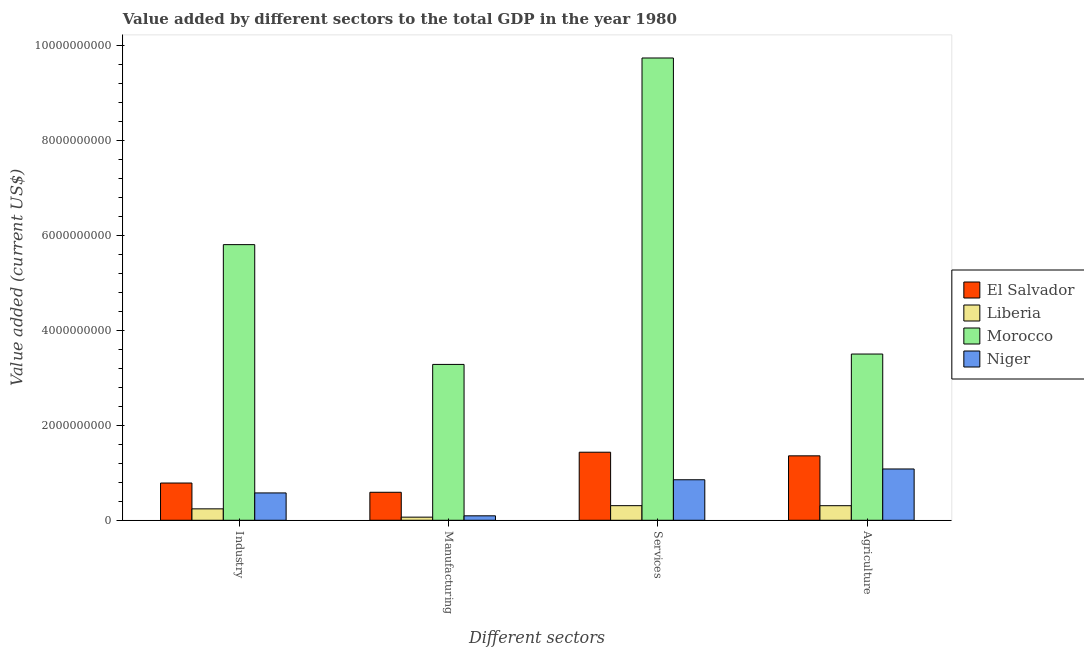How many different coloured bars are there?
Provide a succinct answer. 4. Are the number of bars per tick equal to the number of legend labels?
Make the answer very short. Yes. Are the number of bars on each tick of the X-axis equal?
Your answer should be very brief. Yes. How many bars are there on the 2nd tick from the left?
Offer a terse response. 4. What is the label of the 2nd group of bars from the left?
Give a very brief answer. Manufacturing. What is the value added by agricultural sector in Morocco?
Your answer should be very brief. 3.50e+09. Across all countries, what is the maximum value added by manufacturing sector?
Provide a succinct answer. 3.28e+09. Across all countries, what is the minimum value added by manufacturing sector?
Your response must be concise. 6.57e+07. In which country was the value added by industrial sector maximum?
Your answer should be very brief. Morocco. In which country was the value added by manufacturing sector minimum?
Make the answer very short. Liberia. What is the total value added by manufacturing sector in the graph?
Ensure brevity in your answer.  4.03e+09. What is the difference between the value added by services sector in Niger and that in Morocco?
Make the answer very short. -8.88e+09. What is the difference between the value added by agricultural sector in El Salvador and the value added by services sector in Niger?
Make the answer very short. 5.04e+08. What is the average value added by manufacturing sector per country?
Offer a very short reply. 1.01e+09. What is the difference between the value added by services sector and value added by industrial sector in Morocco?
Keep it short and to the point. 3.93e+09. What is the ratio of the value added by industrial sector in Niger to that in Morocco?
Your response must be concise. 0.1. Is the value added by manufacturing sector in El Salvador less than that in Liberia?
Keep it short and to the point. No. What is the difference between the highest and the second highest value added by industrial sector?
Provide a succinct answer. 5.02e+09. What is the difference between the highest and the lowest value added by services sector?
Your answer should be very brief. 9.43e+09. What does the 2nd bar from the left in Agriculture represents?
Make the answer very short. Liberia. What does the 3rd bar from the right in Services represents?
Give a very brief answer. Liberia. Is it the case that in every country, the sum of the value added by industrial sector and value added by manufacturing sector is greater than the value added by services sector?
Your response must be concise. No. How many bars are there?
Make the answer very short. 16. What is the difference between two consecutive major ticks on the Y-axis?
Ensure brevity in your answer.  2.00e+09. Does the graph contain grids?
Your response must be concise. No. Where does the legend appear in the graph?
Your answer should be compact. Center right. What is the title of the graph?
Offer a terse response. Value added by different sectors to the total GDP in the year 1980. What is the label or title of the X-axis?
Give a very brief answer. Different sectors. What is the label or title of the Y-axis?
Offer a terse response. Value added (current US$). What is the Value added (current US$) in El Salvador in Industry?
Offer a very short reply. 7.84e+08. What is the Value added (current US$) of Liberia in Industry?
Ensure brevity in your answer.  2.40e+08. What is the Value added (current US$) of Morocco in Industry?
Offer a very short reply. 5.80e+09. What is the Value added (current US$) of Niger in Industry?
Provide a succinct answer. 5.76e+08. What is the Value added (current US$) in El Salvador in Manufacturing?
Provide a short and direct response. 5.89e+08. What is the Value added (current US$) in Liberia in Manufacturing?
Keep it short and to the point. 6.57e+07. What is the Value added (current US$) of Morocco in Manufacturing?
Offer a very short reply. 3.28e+09. What is the Value added (current US$) of Niger in Manufacturing?
Ensure brevity in your answer.  9.37e+07. What is the Value added (current US$) in El Salvador in Services?
Your answer should be compact. 1.43e+09. What is the Value added (current US$) in Liberia in Services?
Provide a short and direct response. 3.08e+08. What is the Value added (current US$) of Morocco in Services?
Ensure brevity in your answer.  9.73e+09. What is the Value added (current US$) in Niger in Services?
Make the answer very short. 8.53e+08. What is the Value added (current US$) of El Salvador in Agriculture?
Give a very brief answer. 1.36e+09. What is the Value added (current US$) of Liberia in Agriculture?
Ensure brevity in your answer.  3.07e+08. What is the Value added (current US$) in Morocco in Agriculture?
Ensure brevity in your answer.  3.50e+09. What is the Value added (current US$) of Niger in Agriculture?
Your answer should be very brief. 1.08e+09. Across all Different sectors, what is the maximum Value added (current US$) of El Salvador?
Provide a short and direct response. 1.43e+09. Across all Different sectors, what is the maximum Value added (current US$) of Liberia?
Give a very brief answer. 3.08e+08. Across all Different sectors, what is the maximum Value added (current US$) in Morocco?
Your answer should be very brief. 9.73e+09. Across all Different sectors, what is the maximum Value added (current US$) of Niger?
Ensure brevity in your answer.  1.08e+09. Across all Different sectors, what is the minimum Value added (current US$) in El Salvador?
Keep it short and to the point. 5.89e+08. Across all Different sectors, what is the minimum Value added (current US$) of Liberia?
Make the answer very short. 6.57e+07. Across all Different sectors, what is the minimum Value added (current US$) of Morocco?
Offer a terse response. 3.28e+09. Across all Different sectors, what is the minimum Value added (current US$) of Niger?
Your answer should be compact. 9.37e+07. What is the total Value added (current US$) of El Salvador in the graph?
Keep it short and to the point. 4.16e+09. What is the total Value added (current US$) of Liberia in the graph?
Make the answer very short. 9.20e+08. What is the total Value added (current US$) of Morocco in the graph?
Offer a terse response. 2.23e+1. What is the total Value added (current US$) of Niger in the graph?
Provide a succinct answer. 2.60e+09. What is the difference between the Value added (current US$) in El Salvador in Industry and that in Manufacturing?
Your answer should be compact. 1.95e+08. What is the difference between the Value added (current US$) of Liberia in Industry and that in Manufacturing?
Give a very brief answer. 1.75e+08. What is the difference between the Value added (current US$) of Morocco in Industry and that in Manufacturing?
Ensure brevity in your answer.  2.52e+09. What is the difference between the Value added (current US$) of Niger in Industry and that in Manufacturing?
Give a very brief answer. 4.82e+08. What is the difference between the Value added (current US$) in El Salvador in Industry and that in Services?
Provide a short and direct response. -6.49e+08. What is the difference between the Value added (current US$) of Liberia in Industry and that in Services?
Give a very brief answer. -6.71e+07. What is the difference between the Value added (current US$) of Morocco in Industry and that in Services?
Ensure brevity in your answer.  -3.93e+09. What is the difference between the Value added (current US$) in Niger in Industry and that in Services?
Your response must be concise. -2.77e+08. What is the difference between the Value added (current US$) in El Salvador in Industry and that in Agriculture?
Give a very brief answer. -5.72e+08. What is the difference between the Value added (current US$) in Liberia in Industry and that in Agriculture?
Your answer should be compact. -6.63e+07. What is the difference between the Value added (current US$) in Morocco in Industry and that in Agriculture?
Your answer should be very brief. 2.30e+09. What is the difference between the Value added (current US$) in Niger in Industry and that in Agriculture?
Your answer should be very brief. -5.05e+08. What is the difference between the Value added (current US$) in El Salvador in Manufacturing and that in Services?
Ensure brevity in your answer.  -8.44e+08. What is the difference between the Value added (current US$) of Liberia in Manufacturing and that in Services?
Provide a short and direct response. -2.42e+08. What is the difference between the Value added (current US$) in Morocco in Manufacturing and that in Services?
Give a very brief answer. -6.45e+09. What is the difference between the Value added (current US$) of Niger in Manufacturing and that in Services?
Provide a short and direct response. -7.59e+08. What is the difference between the Value added (current US$) of El Salvador in Manufacturing and that in Agriculture?
Offer a terse response. -7.67e+08. What is the difference between the Value added (current US$) in Liberia in Manufacturing and that in Agriculture?
Your response must be concise. -2.41e+08. What is the difference between the Value added (current US$) in Morocco in Manufacturing and that in Agriculture?
Keep it short and to the point. -2.18e+08. What is the difference between the Value added (current US$) in Niger in Manufacturing and that in Agriculture?
Provide a succinct answer. -9.86e+08. What is the difference between the Value added (current US$) of El Salvador in Services and that in Agriculture?
Keep it short and to the point. 7.64e+07. What is the difference between the Value added (current US$) of Liberia in Services and that in Agriculture?
Make the answer very short. 8.54e+05. What is the difference between the Value added (current US$) in Morocco in Services and that in Agriculture?
Offer a very short reply. 6.23e+09. What is the difference between the Value added (current US$) in Niger in Services and that in Agriculture?
Your answer should be very brief. -2.27e+08. What is the difference between the Value added (current US$) in El Salvador in Industry and the Value added (current US$) in Liberia in Manufacturing?
Offer a very short reply. 7.19e+08. What is the difference between the Value added (current US$) of El Salvador in Industry and the Value added (current US$) of Morocco in Manufacturing?
Your answer should be very brief. -2.50e+09. What is the difference between the Value added (current US$) in El Salvador in Industry and the Value added (current US$) in Niger in Manufacturing?
Make the answer very short. 6.91e+08. What is the difference between the Value added (current US$) in Liberia in Industry and the Value added (current US$) in Morocco in Manufacturing?
Offer a terse response. -3.04e+09. What is the difference between the Value added (current US$) of Liberia in Industry and the Value added (current US$) of Niger in Manufacturing?
Give a very brief answer. 1.47e+08. What is the difference between the Value added (current US$) of Morocco in Industry and the Value added (current US$) of Niger in Manufacturing?
Your answer should be compact. 5.71e+09. What is the difference between the Value added (current US$) of El Salvador in Industry and the Value added (current US$) of Liberia in Services?
Your answer should be compact. 4.77e+08. What is the difference between the Value added (current US$) of El Salvador in Industry and the Value added (current US$) of Morocco in Services?
Give a very brief answer. -8.95e+09. What is the difference between the Value added (current US$) of El Salvador in Industry and the Value added (current US$) of Niger in Services?
Offer a very short reply. -6.86e+07. What is the difference between the Value added (current US$) of Liberia in Industry and the Value added (current US$) of Morocco in Services?
Give a very brief answer. -9.49e+09. What is the difference between the Value added (current US$) in Liberia in Industry and the Value added (current US$) in Niger in Services?
Your answer should be very brief. -6.12e+08. What is the difference between the Value added (current US$) of Morocco in Industry and the Value added (current US$) of Niger in Services?
Provide a succinct answer. 4.95e+09. What is the difference between the Value added (current US$) in El Salvador in Industry and the Value added (current US$) in Liberia in Agriculture?
Your answer should be compact. 4.78e+08. What is the difference between the Value added (current US$) of El Salvador in Industry and the Value added (current US$) of Morocco in Agriculture?
Give a very brief answer. -2.72e+09. What is the difference between the Value added (current US$) in El Salvador in Industry and the Value added (current US$) in Niger in Agriculture?
Offer a terse response. -2.96e+08. What is the difference between the Value added (current US$) in Liberia in Industry and the Value added (current US$) in Morocco in Agriculture?
Make the answer very short. -3.26e+09. What is the difference between the Value added (current US$) in Liberia in Industry and the Value added (current US$) in Niger in Agriculture?
Ensure brevity in your answer.  -8.40e+08. What is the difference between the Value added (current US$) of Morocco in Industry and the Value added (current US$) of Niger in Agriculture?
Your response must be concise. 4.72e+09. What is the difference between the Value added (current US$) of El Salvador in Manufacturing and the Value added (current US$) of Liberia in Services?
Provide a succinct answer. 2.82e+08. What is the difference between the Value added (current US$) in El Salvador in Manufacturing and the Value added (current US$) in Morocco in Services?
Ensure brevity in your answer.  -9.14e+09. What is the difference between the Value added (current US$) of El Salvador in Manufacturing and the Value added (current US$) of Niger in Services?
Make the answer very short. -2.63e+08. What is the difference between the Value added (current US$) of Liberia in Manufacturing and the Value added (current US$) of Morocco in Services?
Offer a very short reply. -9.67e+09. What is the difference between the Value added (current US$) of Liberia in Manufacturing and the Value added (current US$) of Niger in Services?
Your answer should be compact. -7.87e+08. What is the difference between the Value added (current US$) of Morocco in Manufacturing and the Value added (current US$) of Niger in Services?
Keep it short and to the point. 2.43e+09. What is the difference between the Value added (current US$) of El Salvador in Manufacturing and the Value added (current US$) of Liberia in Agriculture?
Offer a terse response. 2.83e+08. What is the difference between the Value added (current US$) in El Salvador in Manufacturing and the Value added (current US$) in Morocco in Agriculture?
Ensure brevity in your answer.  -2.91e+09. What is the difference between the Value added (current US$) in El Salvador in Manufacturing and the Value added (current US$) in Niger in Agriculture?
Give a very brief answer. -4.91e+08. What is the difference between the Value added (current US$) in Liberia in Manufacturing and the Value added (current US$) in Morocco in Agriculture?
Your response must be concise. -3.43e+09. What is the difference between the Value added (current US$) in Liberia in Manufacturing and the Value added (current US$) in Niger in Agriculture?
Your answer should be compact. -1.01e+09. What is the difference between the Value added (current US$) of Morocco in Manufacturing and the Value added (current US$) of Niger in Agriculture?
Give a very brief answer. 2.20e+09. What is the difference between the Value added (current US$) in El Salvador in Services and the Value added (current US$) in Liberia in Agriculture?
Your answer should be very brief. 1.13e+09. What is the difference between the Value added (current US$) of El Salvador in Services and the Value added (current US$) of Morocco in Agriculture?
Provide a short and direct response. -2.07e+09. What is the difference between the Value added (current US$) in El Salvador in Services and the Value added (current US$) in Niger in Agriculture?
Offer a very short reply. 3.53e+08. What is the difference between the Value added (current US$) in Liberia in Services and the Value added (current US$) in Morocco in Agriculture?
Provide a succinct answer. -3.19e+09. What is the difference between the Value added (current US$) of Liberia in Services and the Value added (current US$) of Niger in Agriculture?
Offer a terse response. -7.73e+08. What is the difference between the Value added (current US$) of Morocco in Services and the Value added (current US$) of Niger in Agriculture?
Your answer should be very brief. 8.65e+09. What is the average Value added (current US$) of El Salvador per Different sectors?
Keep it short and to the point. 1.04e+09. What is the average Value added (current US$) of Liberia per Different sectors?
Offer a terse response. 2.30e+08. What is the average Value added (current US$) of Morocco per Different sectors?
Offer a very short reply. 5.58e+09. What is the average Value added (current US$) of Niger per Different sectors?
Offer a terse response. 6.51e+08. What is the difference between the Value added (current US$) in El Salvador and Value added (current US$) in Liberia in Industry?
Provide a succinct answer. 5.44e+08. What is the difference between the Value added (current US$) of El Salvador and Value added (current US$) of Morocco in Industry?
Ensure brevity in your answer.  -5.02e+09. What is the difference between the Value added (current US$) of El Salvador and Value added (current US$) of Niger in Industry?
Make the answer very short. 2.09e+08. What is the difference between the Value added (current US$) in Liberia and Value added (current US$) in Morocco in Industry?
Your answer should be compact. -5.56e+09. What is the difference between the Value added (current US$) in Liberia and Value added (current US$) in Niger in Industry?
Your response must be concise. -3.35e+08. What is the difference between the Value added (current US$) in Morocco and Value added (current US$) in Niger in Industry?
Give a very brief answer. 5.23e+09. What is the difference between the Value added (current US$) in El Salvador and Value added (current US$) in Liberia in Manufacturing?
Your answer should be very brief. 5.24e+08. What is the difference between the Value added (current US$) of El Salvador and Value added (current US$) of Morocco in Manufacturing?
Ensure brevity in your answer.  -2.69e+09. What is the difference between the Value added (current US$) of El Salvador and Value added (current US$) of Niger in Manufacturing?
Provide a succinct answer. 4.96e+08. What is the difference between the Value added (current US$) of Liberia and Value added (current US$) of Morocco in Manufacturing?
Your answer should be compact. -3.22e+09. What is the difference between the Value added (current US$) of Liberia and Value added (current US$) of Niger in Manufacturing?
Ensure brevity in your answer.  -2.80e+07. What is the difference between the Value added (current US$) in Morocco and Value added (current US$) in Niger in Manufacturing?
Keep it short and to the point. 3.19e+09. What is the difference between the Value added (current US$) in El Salvador and Value added (current US$) in Liberia in Services?
Offer a very short reply. 1.13e+09. What is the difference between the Value added (current US$) of El Salvador and Value added (current US$) of Morocco in Services?
Offer a terse response. -8.30e+09. What is the difference between the Value added (current US$) in El Salvador and Value added (current US$) in Niger in Services?
Your response must be concise. 5.80e+08. What is the difference between the Value added (current US$) of Liberia and Value added (current US$) of Morocco in Services?
Give a very brief answer. -9.43e+09. What is the difference between the Value added (current US$) of Liberia and Value added (current US$) of Niger in Services?
Your answer should be compact. -5.45e+08. What is the difference between the Value added (current US$) in Morocco and Value added (current US$) in Niger in Services?
Offer a very short reply. 8.88e+09. What is the difference between the Value added (current US$) of El Salvador and Value added (current US$) of Liberia in Agriculture?
Your answer should be very brief. 1.05e+09. What is the difference between the Value added (current US$) of El Salvador and Value added (current US$) of Morocco in Agriculture?
Keep it short and to the point. -2.14e+09. What is the difference between the Value added (current US$) of El Salvador and Value added (current US$) of Niger in Agriculture?
Provide a succinct answer. 2.77e+08. What is the difference between the Value added (current US$) in Liberia and Value added (current US$) in Morocco in Agriculture?
Give a very brief answer. -3.19e+09. What is the difference between the Value added (current US$) of Liberia and Value added (current US$) of Niger in Agriculture?
Your response must be concise. -7.73e+08. What is the difference between the Value added (current US$) of Morocco and Value added (current US$) of Niger in Agriculture?
Offer a terse response. 2.42e+09. What is the ratio of the Value added (current US$) in El Salvador in Industry to that in Manufacturing?
Offer a very short reply. 1.33. What is the ratio of the Value added (current US$) of Liberia in Industry to that in Manufacturing?
Your answer should be very brief. 3.66. What is the ratio of the Value added (current US$) of Morocco in Industry to that in Manufacturing?
Provide a succinct answer. 1.77. What is the ratio of the Value added (current US$) of Niger in Industry to that in Manufacturing?
Your answer should be very brief. 6.14. What is the ratio of the Value added (current US$) in El Salvador in Industry to that in Services?
Keep it short and to the point. 0.55. What is the ratio of the Value added (current US$) of Liberia in Industry to that in Services?
Provide a short and direct response. 0.78. What is the ratio of the Value added (current US$) in Morocco in Industry to that in Services?
Offer a terse response. 0.6. What is the ratio of the Value added (current US$) of Niger in Industry to that in Services?
Keep it short and to the point. 0.67. What is the ratio of the Value added (current US$) of El Salvador in Industry to that in Agriculture?
Provide a succinct answer. 0.58. What is the ratio of the Value added (current US$) in Liberia in Industry to that in Agriculture?
Give a very brief answer. 0.78. What is the ratio of the Value added (current US$) of Morocco in Industry to that in Agriculture?
Provide a short and direct response. 1.66. What is the ratio of the Value added (current US$) in Niger in Industry to that in Agriculture?
Your response must be concise. 0.53. What is the ratio of the Value added (current US$) in El Salvador in Manufacturing to that in Services?
Offer a very short reply. 0.41. What is the ratio of the Value added (current US$) of Liberia in Manufacturing to that in Services?
Offer a terse response. 0.21. What is the ratio of the Value added (current US$) of Morocco in Manufacturing to that in Services?
Your response must be concise. 0.34. What is the ratio of the Value added (current US$) in Niger in Manufacturing to that in Services?
Offer a terse response. 0.11. What is the ratio of the Value added (current US$) of El Salvador in Manufacturing to that in Agriculture?
Ensure brevity in your answer.  0.43. What is the ratio of the Value added (current US$) of Liberia in Manufacturing to that in Agriculture?
Offer a terse response. 0.21. What is the ratio of the Value added (current US$) in Morocco in Manufacturing to that in Agriculture?
Ensure brevity in your answer.  0.94. What is the ratio of the Value added (current US$) of Niger in Manufacturing to that in Agriculture?
Give a very brief answer. 0.09. What is the ratio of the Value added (current US$) of El Salvador in Services to that in Agriculture?
Your answer should be compact. 1.06. What is the ratio of the Value added (current US$) in Liberia in Services to that in Agriculture?
Keep it short and to the point. 1. What is the ratio of the Value added (current US$) in Morocco in Services to that in Agriculture?
Give a very brief answer. 2.78. What is the ratio of the Value added (current US$) of Niger in Services to that in Agriculture?
Make the answer very short. 0.79. What is the difference between the highest and the second highest Value added (current US$) in El Salvador?
Offer a very short reply. 7.64e+07. What is the difference between the highest and the second highest Value added (current US$) of Liberia?
Ensure brevity in your answer.  8.54e+05. What is the difference between the highest and the second highest Value added (current US$) in Morocco?
Ensure brevity in your answer.  3.93e+09. What is the difference between the highest and the second highest Value added (current US$) in Niger?
Keep it short and to the point. 2.27e+08. What is the difference between the highest and the lowest Value added (current US$) of El Salvador?
Offer a terse response. 8.44e+08. What is the difference between the highest and the lowest Value added (current US$) in Liberia?
Your answer should be very brief. 2.42e+08. What is the difference between the highest and the lowest Value added (current US$) in Morocco?
Your response must be concise. 6.45e+09. What is the difference between the highest and the lowest Value added (current US$) in Niger?
Your response must be concise. 9.86e+08. 